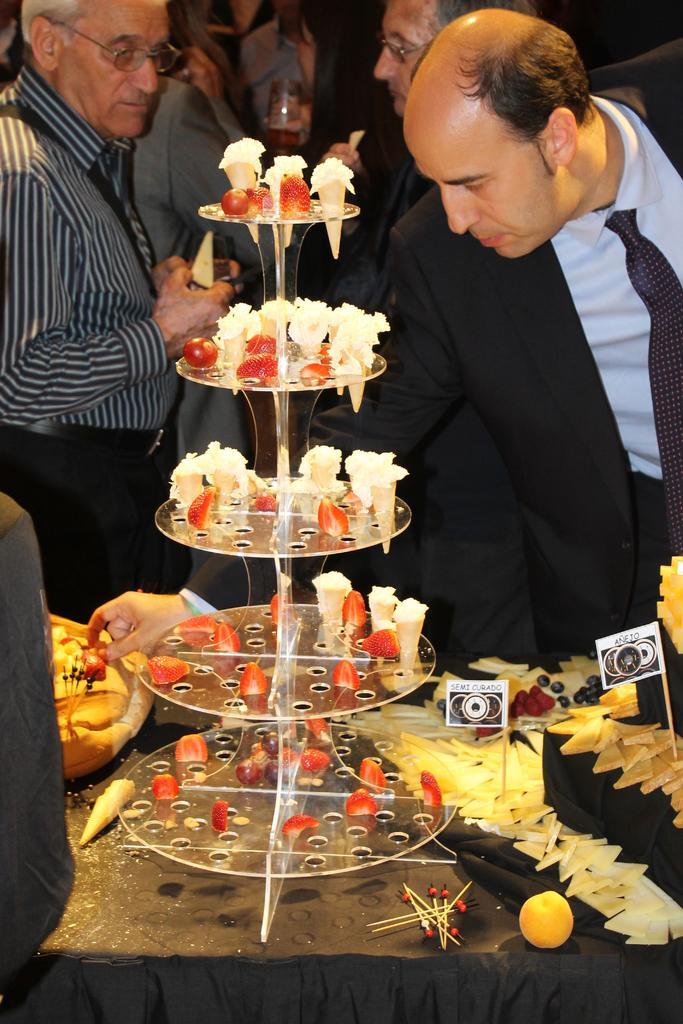Could you give a brief overview of what you see in this image? In this image, we can see a glass stand with edible things. Here there is a cloth. So many things and items are placed on it. Right side of the image, a man is picking an item. Here we can see few people are standing and holding some objects. 